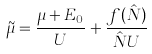Convert formula to latex. <formula><loc_0><loc_0><loc_500><loc_500>\tilde { \mu } = \frac { \mu + E _ { 0 } } { U } + \frac { f ( \hat { N } ) } { \hat { N } U }</formula> 